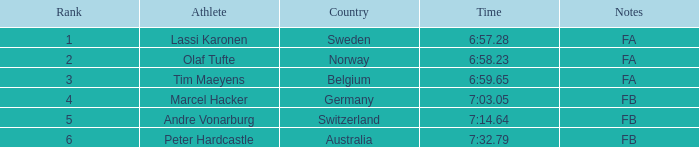What is the lowest rank for Andre Vonarburg, when the notes are FB? 5.0. Could you parse the entire table? {'header': ['Rank', 'Athlete', 'Country', 'Time', 'Notes'], 'rows': [['1', 'Lassi Karonen', 'Sweden', '6:57.28', 'FA'], ['2', 'Olaf Tufte', 'Norway', '6:58.23', 'FA'], ['3', 'Tim Maeyens', 'Belgium', '6:59.65', 'FA'], ['4', 'Marcel Hacker', 'Germany', '7:03.05', 'FB'], ['5', 'Andre Vonarburg', 'Switzerland', '7:14.64', 'FB'], ['6', 'Peter Hardcastle', 'Australia', '7:32.79', 'FB']]} 